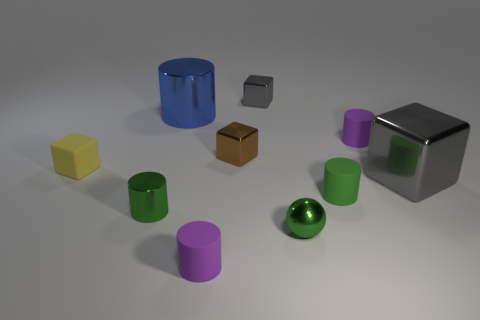Subtract all tiny brown shiny blocks. How many blocks are left? 3 Subtract all blue cylinders. How many cylinders are left? 4 Subtract 1 cylinders. How many cylinders are left? 4 Subtract 1 green balls. How many objects are left? 9 Subtract all blocks. How many objects are left? 6 Subtract all green cylinders. Subtract all green balls. How many cylinders are left? 3 Subtract all yellow cylinders. How many gray cubes are left? 2 Subtract all large objects. Subtract all purple cylinders. How many objects are left? 6 Add 4 tiny green balls. How many tiny green balls are left? 5 Add 4 small brown things. How many small brown things exist? 5 